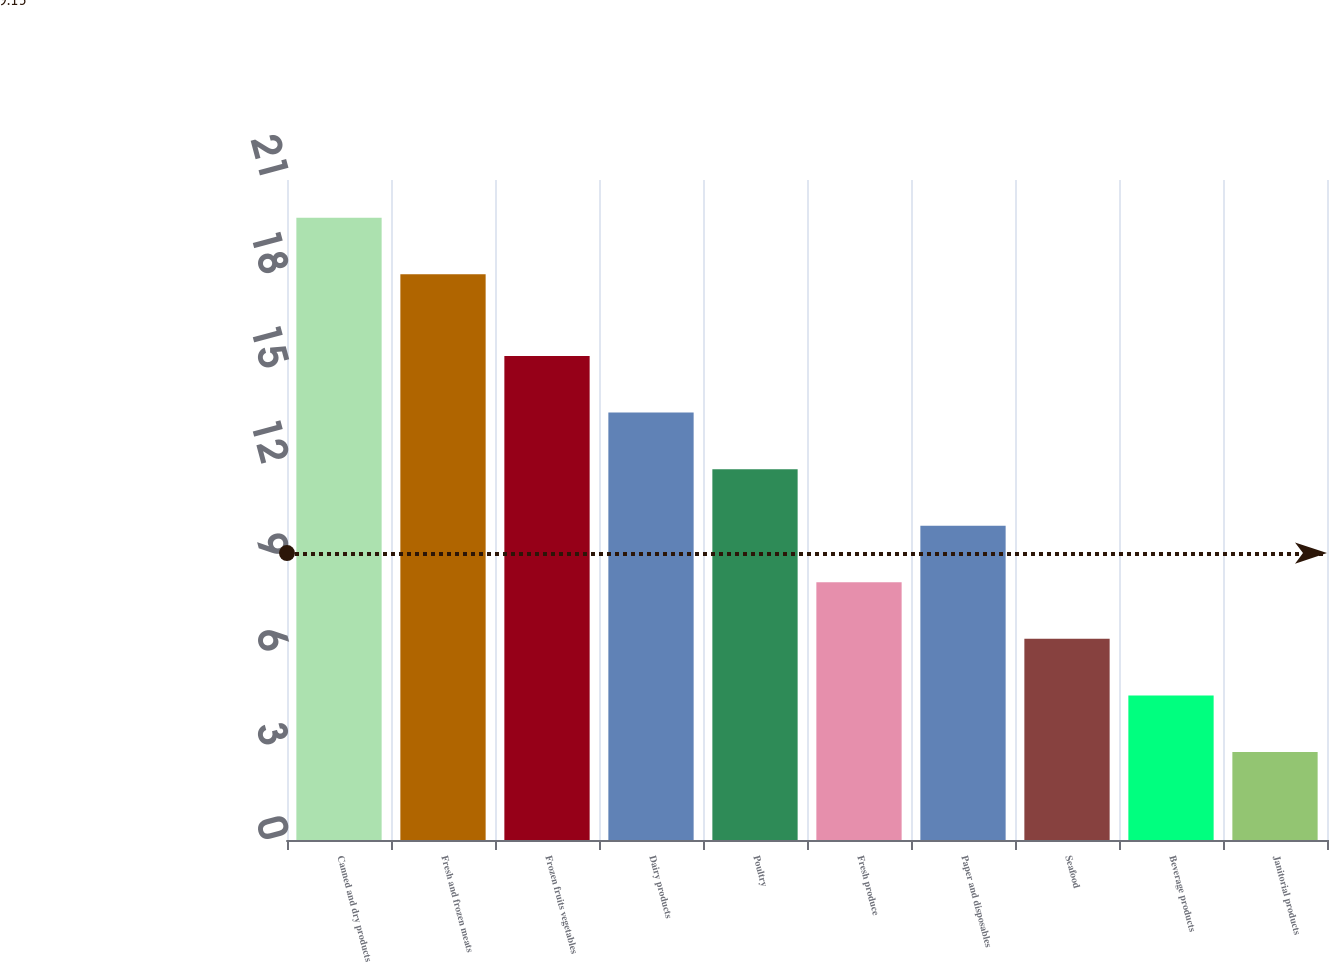Convert chart to OTSL. <chart><loc_0><loc_0><loc_500><loc_500><bar_chart><fcel>Canned and dry products<fcel>Fresh and frozen meats<fcel>Frozen fruits vegetables<fcel>Dairy products<fcel>Poultry<fcel>Fresh produce<fcel>Paper and disposables<fcel>Seafood<fcel>Beverage products<fcel>Janitorial products<nl><fcel>19.8<fcel>18<fcel>15.4<fcel>13.6<fcel>11.8<fcel>8.2<fcel>10<fcel>6.4<fcel>4.6<fcel>2.8<nl></chart> 